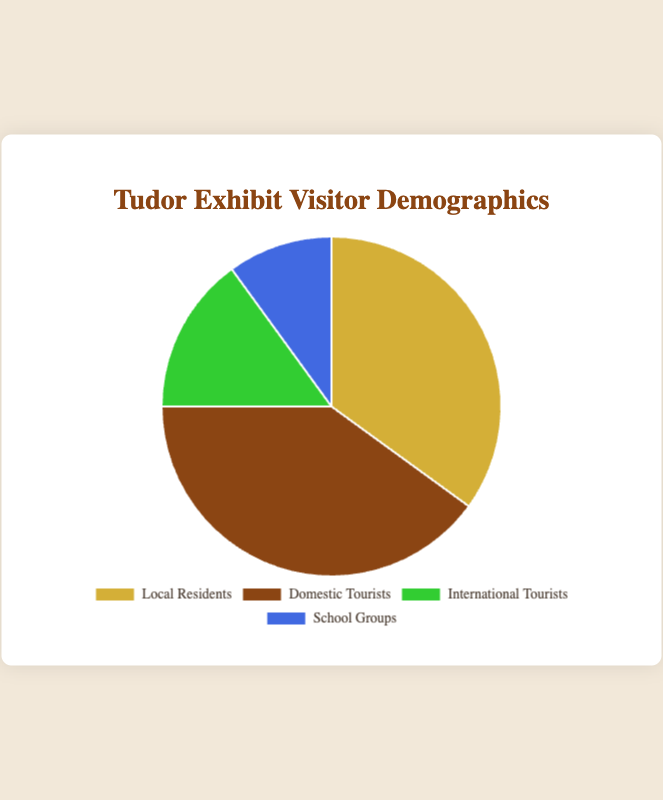What percentage of the visitors are either Local Residents or Domestic Tourists? To find the total percentage of Local Residents and Domestic Tourists, sum their individual percentages: 35% (Local Residents) + 40% (Domestic Tourists) = 75%.
Answer: 75% Which visitor group has the smallest percentage? Compare the percentages of each group: Local Residents (35%), Domestic Tourists (40%), International Tourists (15%), and School Groups (10%). The smallest percentage is for the School Groups.
Answer: School Groups How much larger is the percentage of Domestic Tourists compared to International Tourists? Subtract the percentage of International Tourists from the percentage of Domestic Tourists: 40% (Domestic Tourists) - 15% (International Tourists) = 25%.
Answer: 25% What is the combined percentage of School Groups and International Tourists? To find the combined percentage, sum the percentages of School Groups and International Tourists: 10% (School Groups) + 15% (International Tourists) = 25%.
Answer: 25% Which group represents the largest percentage of visitors? Look at the percentages of each group: Local Residents (35%), Domestic Tourists (40%), International Tourists (15%), and School Groups (10%). Domestic Tourists have the largest percentage.
Answer: Domestic Tourists How many percentage points higher is the percentage of Local Residents than School Groups? Subtract the percentage of School Groups from the percentage of Local Residents: 35% (Local Residents) - 10% (School Groups) = 25%.
Answer: 25% What is the average percentage of visitors for the four groups? Add the percentages of all four groups and divide by the number of groups: (35% + 40% + 15% + 10%) / 4 = 100% / 4 = 25%.
Answer: 25% What color represents International Tourists on the pie chart? The pie chart colors are mapped to the categories, and International Tourists are represented by green.
Answer: Green If a new group was added with 20% of the visitors, what would be the new total percentage for all five groups? Adding the new group's percentage to the current total percentage: 35% (Local Residents) + 40% (Domestic Tourists) + 15% (International Tourists) + 10% (School Groups) + 20% (New Group) = 120%.
Answer: 120% What percentage of visitors are not Domestic Tourists? Subtract the percentage of Domestic Tourists from 100%: 100% - 40% (Domestic Tourists) = 60%.
Answer: 60% 